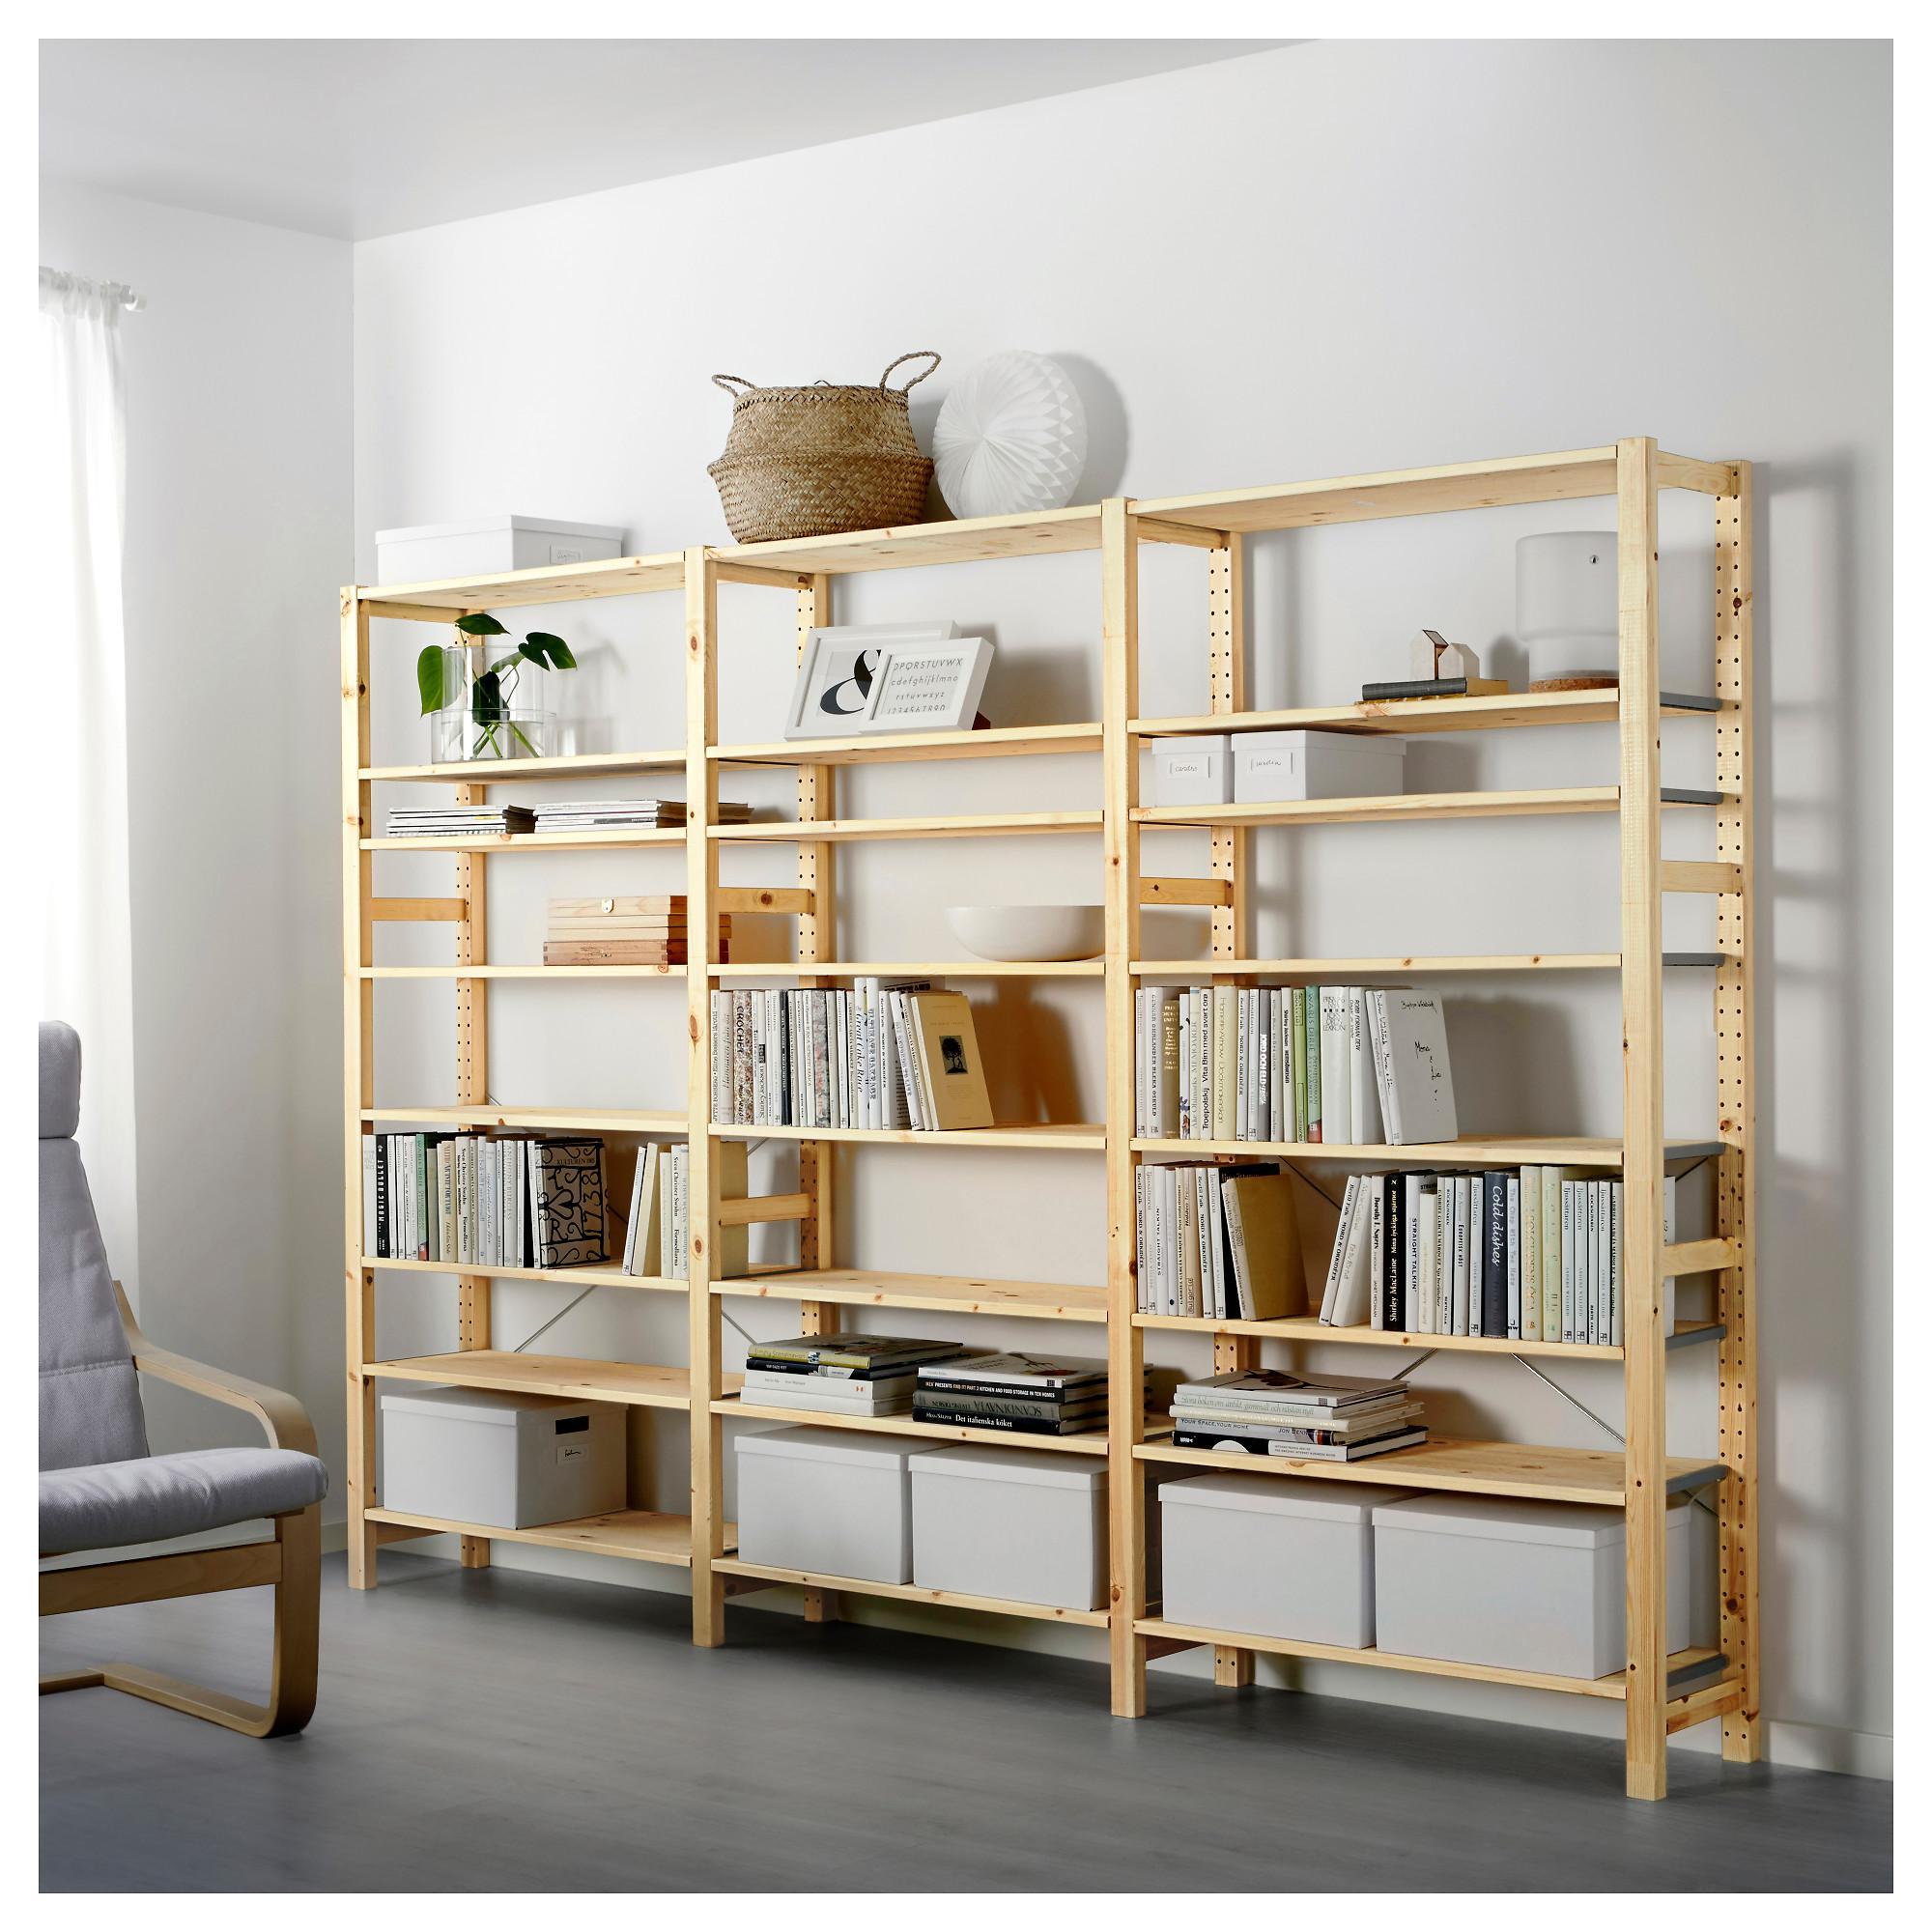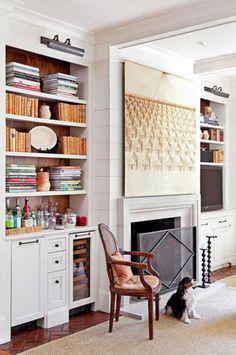The first image is the image on the left, the second image is the image on the right. For the images shown, is this caption "At least one shelving unit is used as behind the fridge pantry space." true? Answer yes or no. No. The first image is the image on the left, the second image is the image on the right. Examine the images to the left and right. Is the description "A narrow white pantry with filled shelves is extended out alongside a white refrigerator with no magnets on it, in the left image." accurate? Answer yes or no. No. 